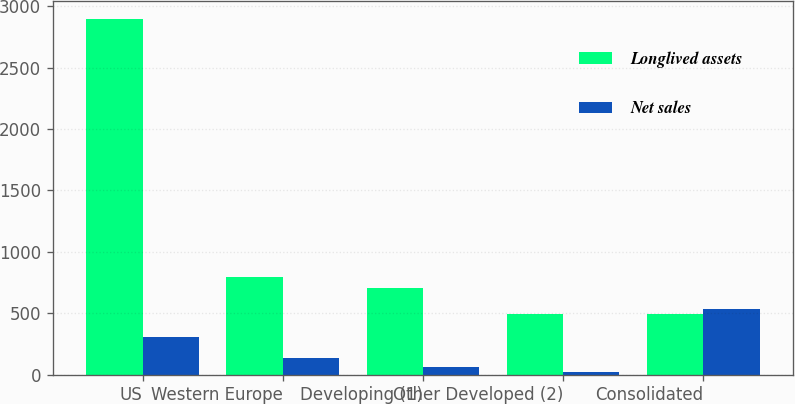<chart> <loc_0><loc_0><loc_500><loc_500><stacked_bar_chart><ecel><fcel>US<fcel>Western Europe<fcel>Developing (1)<fcel>Other Developed (2)<fcel>Consolidated<nl><fcel>Longlived assets<fcel>2897.1<fcel>796<fcel>704<fcel>492.9<fcel>492.9<nl><fcel>Net sales<fcel>309.5<fcel>138.6<fcel>65.2<fcel>25.3<fcel>538.6<nl></chart> 